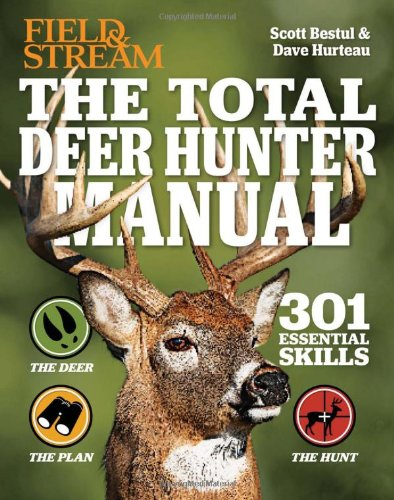What is the genre of this book? This book is primarily a hunting reference guide, specifically designed for deer hunters looking to enhance their skills in the field. 